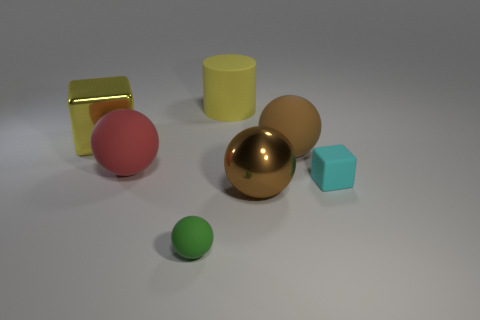Subtract all large metal balls. How many balls are left? 3 Add 1 blue cylinders. How many objects exist? 8 Subtract 1 blocks. How many blocks are left? 1 Subtract all balls. How many objects are left? 3 Subtract all green spheres. How many spheres are left? 3 Subtract all red balls. Subtract all gray cylinders. How many balls are left? 3 Subtract all gray cylinders. How many purple spheres are left? 0 Subtract all big purple blocks. Subtract all rubber objects. How many objects are left? 2 Add 2 red matte balls. How many red matte balls are left? 3 Add 2 yellow matte things. How many yellow matte things exist? 3 